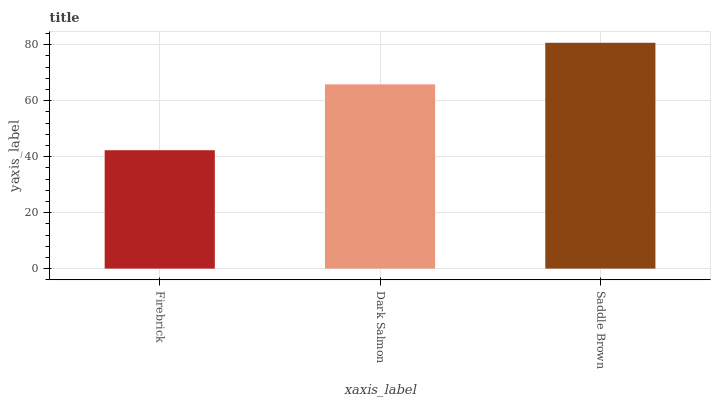Is Dark Salmon the minimum?
Answer yes or no. No. Is Dark Salmon the maximum?
Answer yes or no. No. Is Dark Salmon greater than Firebrick?
Answer yes or no. Yes. Is Firebrick less than Dark Salmon?
Answer yes or no. Yes. Is Firebrick greater than Dark Salmon?
Answer yes or no. No. Is Dark Salmon less than Firebrick?
Answer yes or no. No. Is Dark Salmon the high median?
Answer yes or no. Yes. Is Dark Salmon the low median?
Answer yes or no. Yes. Is Saddle Brown the high median?
Answer yes or no. No. Is Saddle Brown the low median?
Answer yes or no. No. 